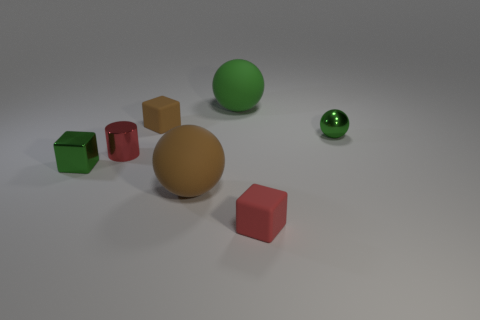How does the lighting in the image affect the appearance of the objects? The lighting creates a soft shadow under each object, enhancing their three-dimensional appearance, and it also highlights the difference in texture between the shiny and matte surfaces. Does the shadow direction tell us anything about the light source? Yes, the shadows fall mostly to the right of the objects, which indicates that the primary light source is to the left. 